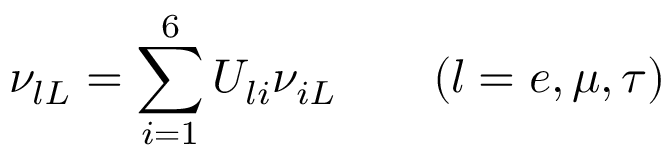Convert formula to latex. <formula><loc_0><loc_0><loc_500><loc_500>\nu _ { l L } = \sum _ { i = 1 } ^ { 6 } U _ { l i } \nu _ { i L } \quad ( l = e , \mu , \tau )</formula> 